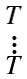Convert formula to latex. <formula><loc_0><loc_0><loc_500><loc_500>\begin{smallmatrix} T \\ \vdots \\ T \end{smallmatrix}</formula> 